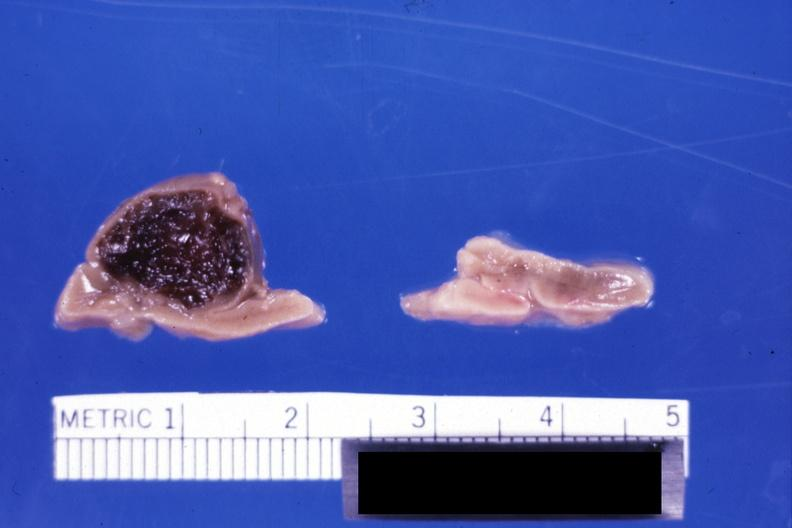what is present?
Answer the question using a single word or phrase. Adrenal 